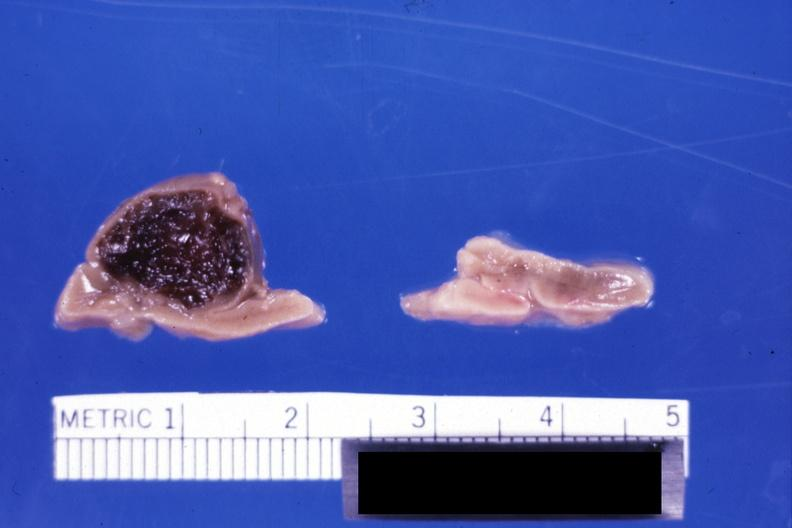what is present?
Answer the question using a single word or phrase. Adrenal 